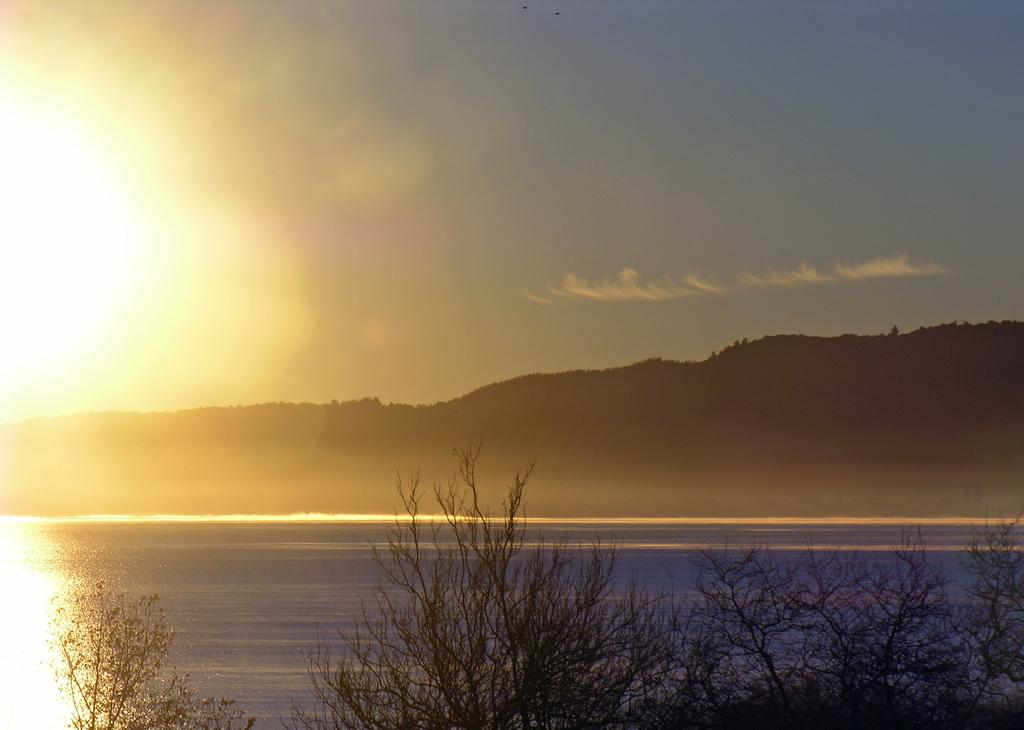What type of natural environment is depicted in the image? The image features trees, a river, and a mountain, indicating a natural environment. What can be seen in the background of the image? The sky is visible in the image. Can you describe the landscape in the image? The landscape includes trees, a river, and a mountain. What type of cloth is draped over the chairs in the image? There are no chairs or cloth present in the image; it features trees, a river, and a mountain. 